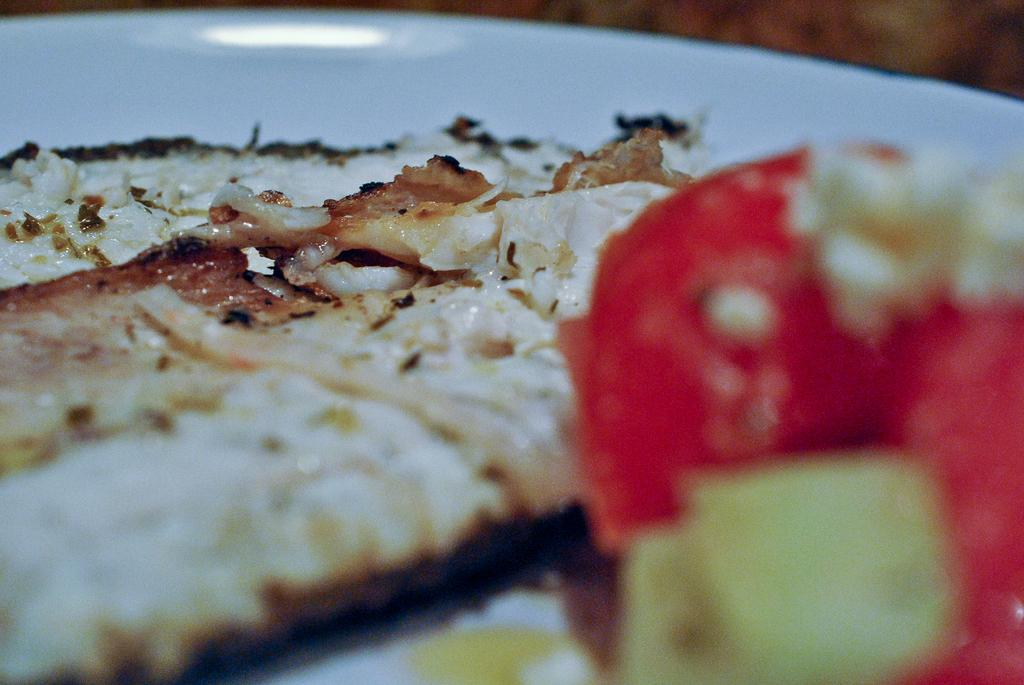What is present in the image related to food? There is food in the image. How is the food presented in the image? The food is on a white color plate. What colors can be observed in the food? The food has colors such as white, brown, red, and green. How many locks can be seen securing the food in the image? There are no locks present in the image; the food is on a plate. What type of kittens can be seen playing with the food in the image? There are no kittens present in the image; it only features food on a plate. 